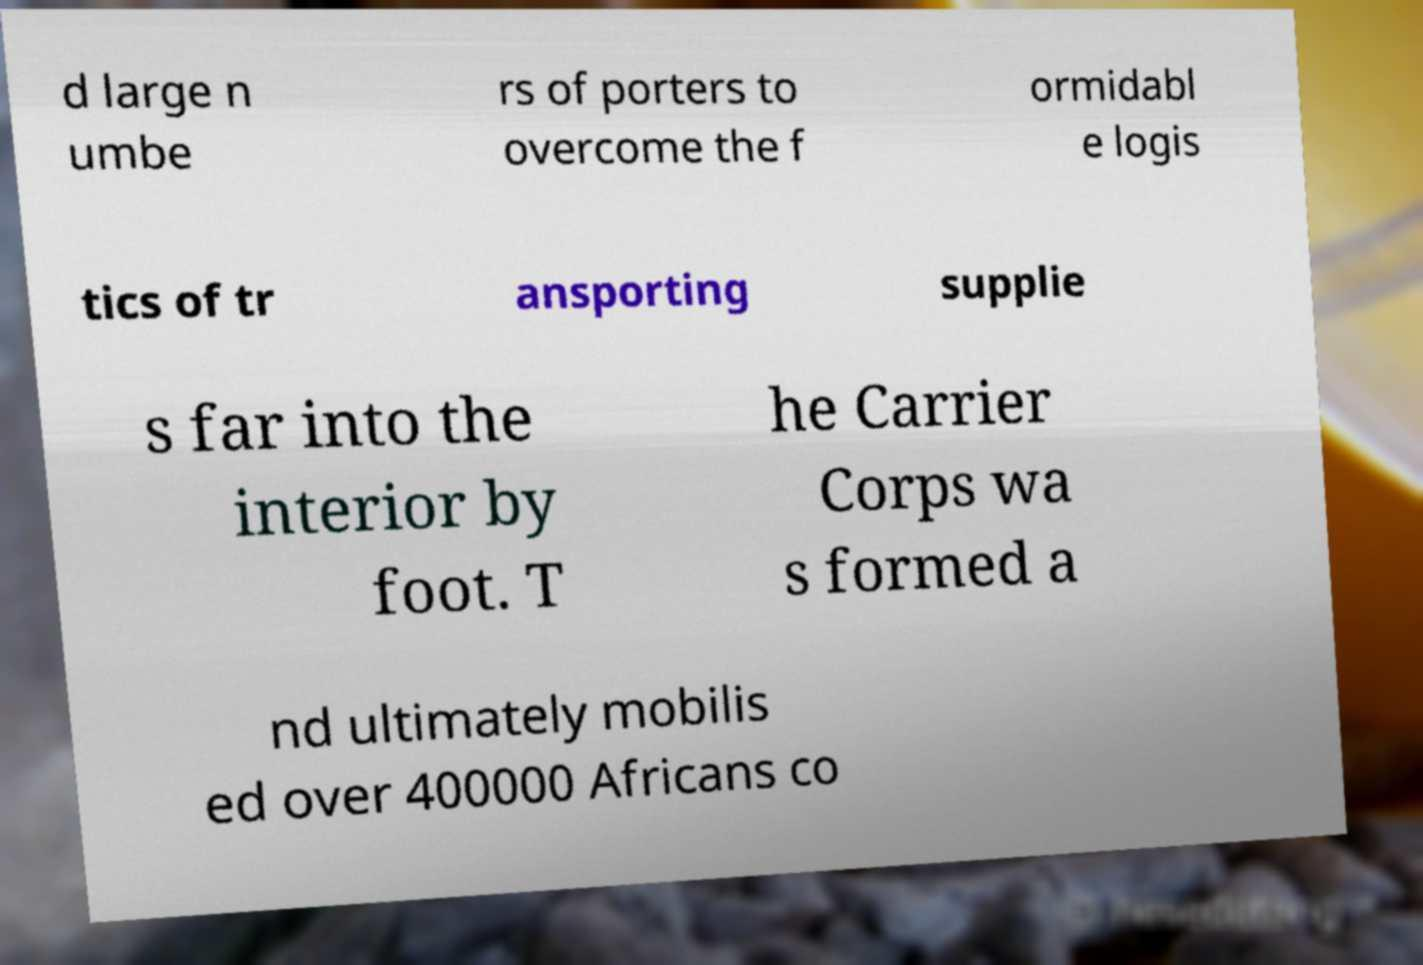Please identify and transcribe the text found in this image. d large n umbe rs of porters to overcome the f ormidabl e logis tics of tr ansporting supplie s far into the interior by foot. T he Carrier Corps wa s formed a nd ultimately mobilis ed over 400000 Africans co 